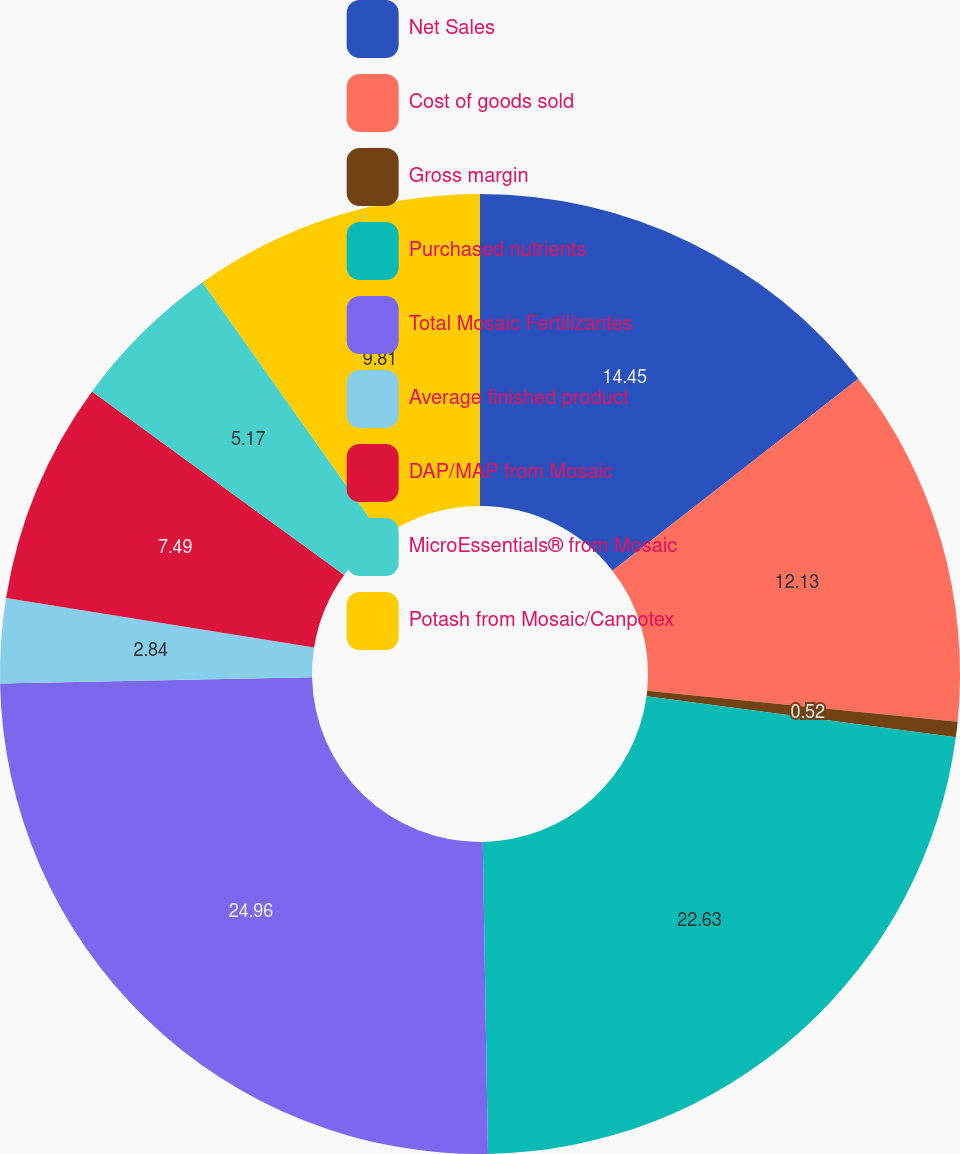Convert chart to OTSL. <chart><loc_0><loc_0><loc_500><loc_500><pie_chart><fcel>Net Sales<fcel>Cost of goods sold<fcel>Gross margin<fcel>Purchased nutrients<fcel>Total Mosaic Fertilizantes<fcel>Average finished product<fcel>DAP/MAP from Mosaic<fcel>MicroEssentials® from Mosaic<fcel>Potash from Mosaic/Canpotex<nl><fcel>14.45%<fcel>12.13%<fcel>0.52%<fcel>22.63%<fcel>24.95%<fcel>2.84%<fcel>7.49%<fcel>5.17%<fcel>9.81%<nl></chart> 